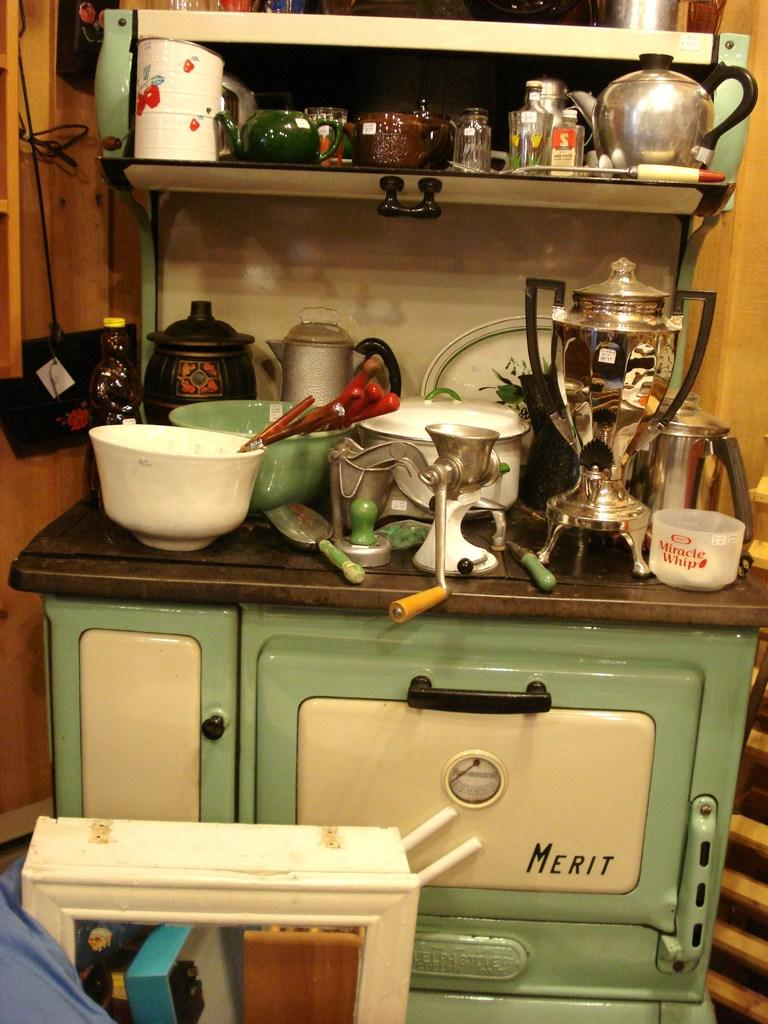<image>
Present a compact description of the photo's key features. a clutterred old fashioned teal and white merit stove 